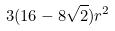<formula> <loc_0><loc_0><loc_500><loc_500>3 ( 1 6 - 8 \sqrt { 2 } ) r ^ { 2 }</formula> 